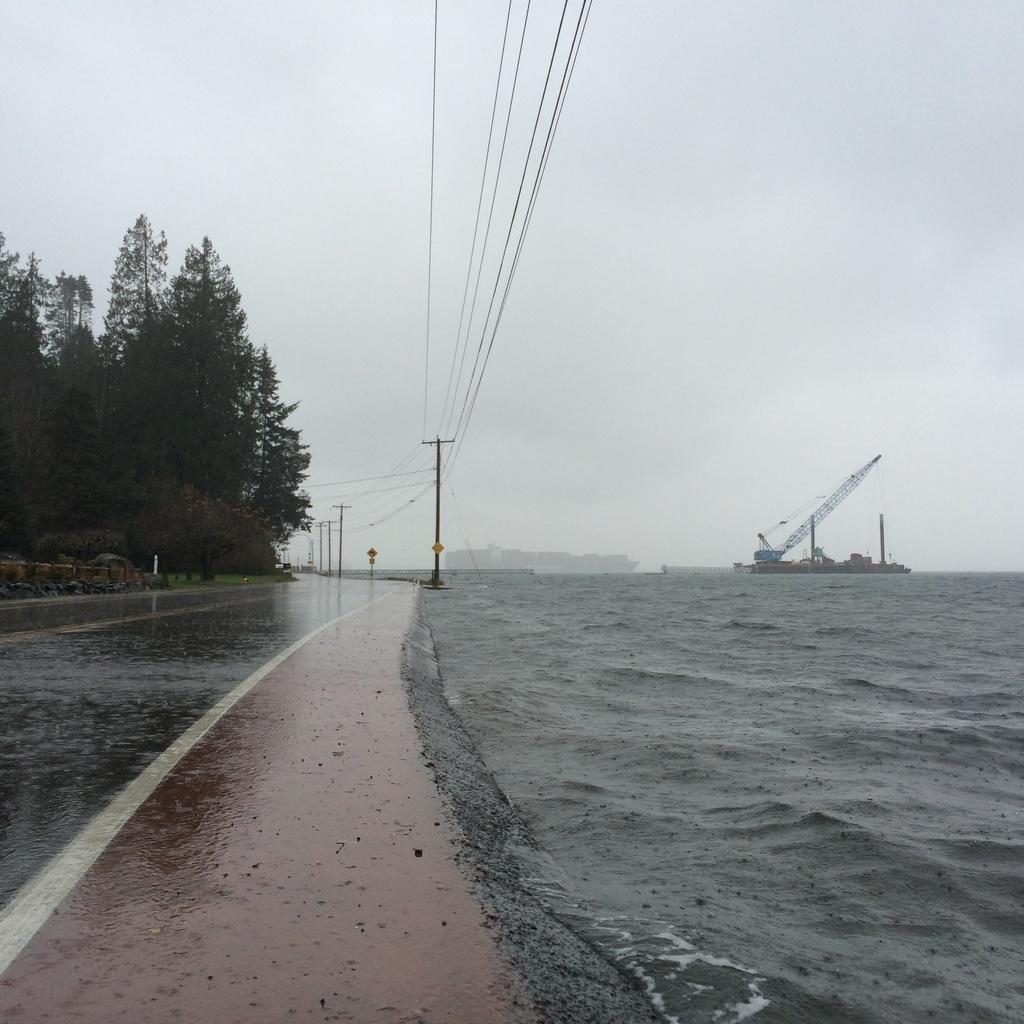How would you summarize this image in a sentence or two? In this image on the left side we can see road, trees, objects, poles, wires, objects on the poles and on the right side we can see ship on the water, crane and objects. In the background we can see clouds in the sky. 